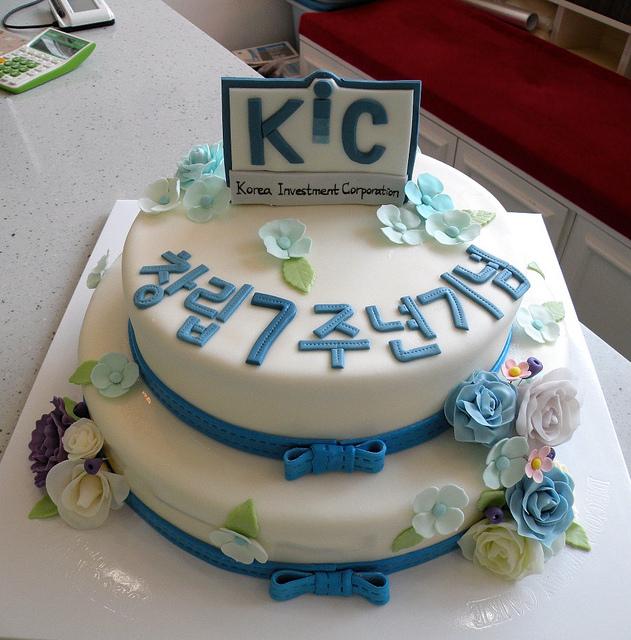What ceremony does the cake commemorate?
Short answer required. Birthday. What is the first letter?
Write a very short answer. K. Is this a birthday cake?
Write a very short answer. Yes. How many layers are there?
Answer briefly. 2. Is this cake homemade?
Be succinct. No. What color are the trim and bows?
Quick response, please. Blue. Is this cake in a box?
Be succinct. No. What does KiC stand for?
Write a very short answer. Korea investment corporation. Is this photo probably taken in the United States?
Be succinct. No. What is written on the cake?
Give a very brief answer. Kic. What type of cake is shown on the foil?
Be succinct. Wedding. Is it birthday cake or wedding cake?
Concise answer only. Birthday. What color is the cake?
Write a very short answer. White. When is the birthday party going to begin?
Quick response, please. Soon. Could this cake be for twins?
Quick response, please. No. What is the cake celebrating?
Give a very brief answer. Birthday. Is this a yellow cake?
Give a very brief answer. No. 